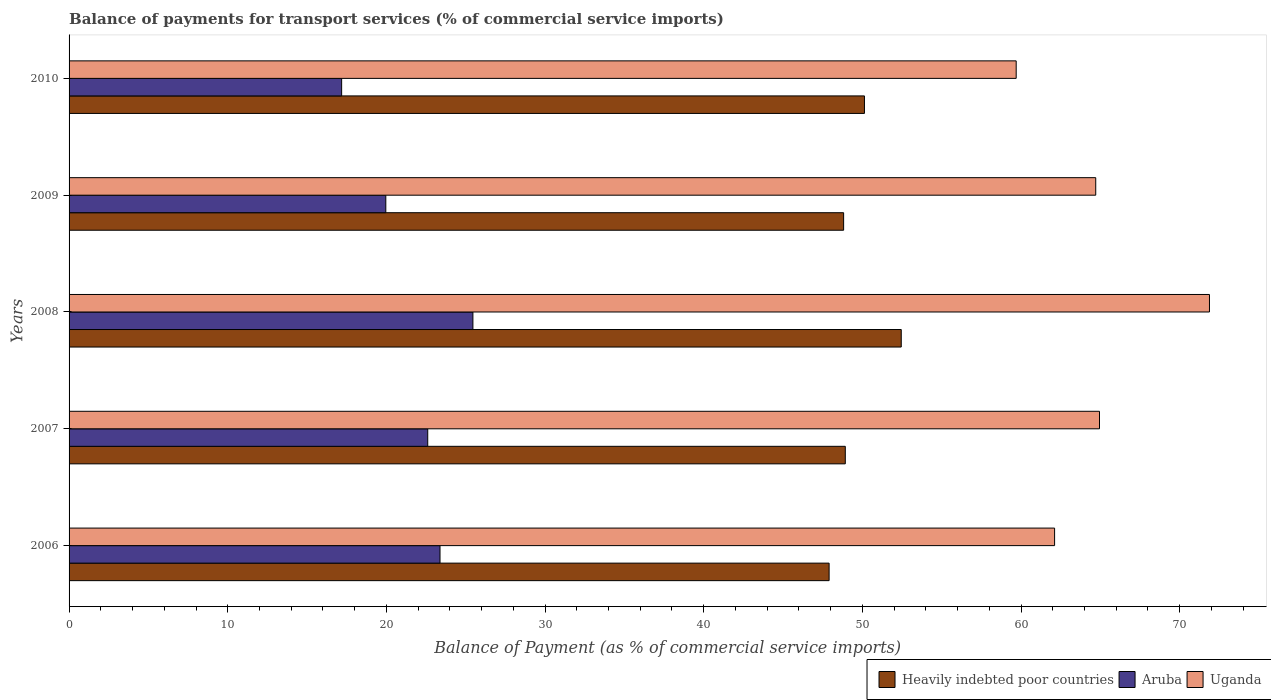How many groups of bars are there?
Your answer should be very brief. 5. Are the number of bars per tick equal to the number of legend labels?
Give a very brief answer. Yes. Are the number of bars on each tick of the Y-axis equal?
Ensure brevity in your answer.  Yes. How many bars are there on the 2nd tick from the top?
Your answer should be compact. 3. How many bars are there on the 5th tick from the bottom?
Your answer should be very brief. 3. What is the label of the 5th group of bars from the top?
Offer a very short reply. 2006. In how many cases, is the number of bars for a given year not equal to the number of legend labels?
Ensure brevity in your answer.  0. What is the balance of payments for transport services in Uganda in 2006?
Make the answer very short. 62.12. Across all years, what is the maximum balance of payments for transport services in Uganda?
Provide a succinct answer. 71.88. Across all years, what is the minimum balance of payments for transport services in Heavily indebted poor countries?
Provide a succinct answer. 47.9. In which year was the balance of payments for transport services in Aruba maximum?
Offer a terse response. 2008. What is the total balance of payments for transport services in Aruba in the graph?
Your response must be concise. 108.58. What is the difference between the balance of payments for transport services in Heavily indebted poor countries in 2007 and that in 2009?
Keep it short and to the point. 0.11. What is the difference between the balance of payments for transport services in Aruba in 2006 and the balance of payments for transport services in Uganda in 2008?
Provide a short and direct response. -48.5. What is the average balance of payments for transport services in Heavily indebted poor countries per year?
Offer a terse response. 49.65. In the year 2007, what is the difference between the balance of payments for transport services in Uganda and balance of payments for transport services in Heavily indebted poor countries?
Your answer should be very brief. 16.02. What is the ratio of the balance of payments for transport services in Heavily indebted poor countries in 2006 to that in 2007?
Your answer should be very brief. 0.98. Is the balance of payments for transport services in Uganda in 2006 less than that in 2008?
Provide a succinct answer. Yes. Is the difference between the balance of payments for transport services in Uganda in 2007 and 2008 greater than the difference between the balance of payments for transport services in Heavily indebted poor countries in 2007 and 2008?
Your answer should be very brief. No. What is the difference between the highest and the second highest balance of payments for transport services in Heavily indebted poor countries?
Offer a terse response. 2.32. What is the difference between the highest and the lowest balance of payments for transport services in Uganda?
Ensure brevity in your answer.  12.18. What does the 1st bar from the top in 2008 represents?
Ensure brevity in your answer.  Uganda. What does the 3rd bar from the bottom in 2008 represents?
Ensure brevity in your answer.  Uganda. Is it the case that in every year, the sum of the balance of payments for transport services in Aruba and balance of payments for transport services in Heavily indebted poor countries is greater than the balance of payments for transport services in Uganda?
Your answer should be very brief. Yes. How many bars are there?
Your response must be concise. 15. Are all the bars in the graph horizontal?
Offer a terse response. Yes. How many years are there in the graph?
Provide a succinct answer. 5. What is the difference between two consecutive major ticks on the X-axis?
Your answer should be very brief. 10. Are the values on the major ticks of X-axis written in scientific E-notation?
Keep it short and to the point. No. Does the graph contain any zero values?
Your answer should be compact. No. Where does the legend appear in the graph?
Your response must be concise. Bottom right. How many legend labels are there?
Offer a terse response. 3. What is the title of the graph?
Ensure brevity in your answer.  Balance of payments for transport services (% of commercial service imports). What is the label or title of the X-axis?
Provide a short and direct response. Balance of Payment (as % of commercial service imports). What is the Balance of Payment (as % of commercial service imports) of Heavily indebted poor countries in 2006?
Ensure brevity in your answer.  47.9. What is the Balance of Payment (as % of commercial service imports) of Aruba in 2006?
Offer a terse response. 23.38. What is the Balance of Payment (as % of commercial service imports) of Uganda in 2006?
Your answer should be very brief. 62.12. What is the Balance of Payment (as % of commercial service imports) in Heavily indebted poor countries in 2007?
Make the answer very short. 48.92. What is the Balance of Payment (as % of commercial service imports) of Aruba in 2007?
Make the answer very short. 22.61. What is the Balance of Payment (as % of commercial service imports) in Uganda in 2007?
Provide a short and direct response. 64.95. What is the Balance of Payment (as % of commercial service imports) of Heavily indebted poor countries in 2008?
Give a very brief answer. 52.45. What is the Balance of Payment (as % of commercial service imports) in Aruba in 2008?
Provide a succinct answer. 25.45. What is the Balance of Payment (as % of commercial service imports) of Uganda in 2008?
Your answer should be compact. 71.88. What is the Balance of Payment (as % of commercial service imports) in Heavily indebted poor countries in 2009?
Keep it short and to the point. 48.82. What is the Balance of Payment (as % of commercial service imports) of Aruba in 2009?
Ensure brevity in your answer.  19.96. What is the Balance of Payment (as % of commercial service imports) of Uganda in 2009?
Keep it short and to the point. 64.71. What is the Balance of Payment (as % of commercial service imports) of Heavily indebted poor countries in 2010?
Offer a very short reply. 50.13. What is the Balance of Payment (as % of commercial service imports) in Aruba in 2010?
Your answer should be very brief. 17.18. What is the Balance of Payment (as % of commercial service imports) of Uganda in 2010?
Your answer should be compact. 59.7. Across all years, what is the maximum Balance of Payment (as % of commercial service imports) of Heavily indebted poor countries?
Offer a very short reply. 52.45. Across all years, what is the maximum Balance of Payment (as % of commercial service imports) of Aruba?
Your answer should be very brief. 25.45. Across all years, what is the maximum Balance of Payment (as % of commercial service imports) of Uganda?
Make the answer very short. 71.88. Across all years, what is the minimum Balance of Payment (as % of commercial service imports) of Heavily indebted poor countries?
Your answer should be compact. 47.9. Across all years, what is the minimum Balance of Payment (as % of commercial service imports) in Aruba?
Keep it short and to the point. 17.18. Across all years, what is the minimum Balance of Payment (as % of commercial service imports) of Uganda?
Your answer should be very brief. 59.7. What is the total Balance of Payment (as % of commercial service imports) in Heavily indebted poor countries in the graph?
Keep it short and to the point. 248.23. What is the total Balance of Payment (as % of commercial service imports) in Aruba in the graph?
Provide a succinct answer. 108.58. What is the total Balance of Payment (as % of commercial service imports) in Uganda in the graph?
Keep it short and to the point. 323.35. What is the difference between the Balance of Payment (as % of commercial service imports) in Heavily indebted poor countries in 2006 and that in 2007?
Make the answer very short. -1.02. What is the difference between the Balance of Payment (as % of commercial service imports) in Aruba in 2006 and that in 2007?
Provide a succinct answer. 0.77. What is the difference between the Balance of Payment (as % of commercial service imports) in Uganda in 2006 and that in 2007?
Keep it short and to the point. -2.83. What is the difference between the Balance of Payment (as % of commercial service imports) in Heavily indebted poor countries in 2006 and that in 2008?
Offer a very short reply. -4.55. What is the difference between the Balance of Payment (as % of commercial service imports) in Aruba in 2006 and that in 2008?
Ensure brevity in your answer.  -2.07. What is the difference between the Balance of Payment (as % of commercial service imports) of Uganda in 2006 and that in 2008?
Provide a succinct answer. -9.76. What is the difference between the Balance of Payment (as % of commercial service imports) in Heavily indebted poor countries in 2006 and that in 2009?
Offer a very short reply. -0.92. What is the difference between the Balance of Payment (as % of commercial service imports) of Aruba in 2006 and that in 2009?
Make the answer very short. 3.42. What is the difference between the Balance of Payment (as % of commercial service imports) of Uganda in 2006 and that in 2009?
Your answer should be compact. -2.59. What is the difference between the Balance of Payment (as % of commercial service imports) of Heavily indebted poor countries in 2006 and that in 2010?
Provide a short and direct response. -2.23. What is the difference between the Balance of Payment (as % of commercial service imports) of Aruba in 2006 and that in 2010?
Make the answer very short. 6.2. What is the difference between the Balance of Payment (as % of commercial service imports) in Uganda in 2006 and that in 2010?
Provide a short and direct response. 2.42. What is the difference between the Balance of Payment (as % of commercial service imports) in Heavily indebted poor countries in 2007 and that in 2008?
Your answer should be very brief. -3.53. What is the difference between the Balance of Payment (as % of commercial service imports) in Aruba in 2007 and that in 2008?
Offer a terse response. -2.85. What is the difference between the Balance of Payment (as % of commercial service imports) in Uganda in 2007 and that in 2008?
Your answer should be very brief. -6.93. What is the difference between the Balance of Payment (as % of commercial service imports) in Heavily indebted poor countries in 2007 and that in 2009?
Provide a short and direct response. 0.11. What is the difference between the Balance of Payment (as % of commercial service imports) of Aruba in 2007 and that in 2009?
Offer a very short reply. 2.64. What is the difference between the Balance of Payment (as % of commercial service imports) in Uganda in 2007 and that in 2009?
Offer a terse response. 0.24. What is the difference between the Balance of Payment (as % of commercial service imports) of Heavily indebted poor countries in 2007 and that in 2010?
Your response must be concise. -1.21. What is the difference between the Balance of Payment (as % of commercial service imports) in Aruba in 2007 and that in 2010?
Give a very brief answer. 5.43. What is the difference between the Balance of Payment (as % of commercial service imports) in Uganda in 2007 and that in 2010?
Keep it short and to the point. 5.25. What is the difference between the Balance of Payment (as % of commercial service imports) of Heavily indebted poor countries in 2008 and that in 2009?
Your response must be concise. 3.63. What is the difference between the Balance of Payment (as % of commercial service imports) of Aruba in 2008 and that in 2009?
Keep it short and to the point. 5.49. What is the difference between the Balance of Payment (as % of commercial service imports) of Uganda in 2008 and that in 2009?
Offer a very short reply. 7.17. What is the difference between the Balance of Payment (as % of commercial service imports) of Heavily indebted poor countries in 2008 and that in 2010?
Your answer should be very brief. 2.32. What is the difference between the Balance of Payment (as % of commercial service imports) of Aruba in 2008 and that in 2010?
Give a very brief answer. 8.27. What is the difference between the Balance of Payment (as % of commercial service imports) in Uganda in 2008 and that in 2010?
Offer a terse response. 12.18. What is the difference between the Balance of Payment (as % of commercial service imports) in Heavily indebted poor countries in 2009 and that in 2010?
Your response must be concise. -1.31. What is the difference between the Balance of Payment (as % of commercial service imports) in Aruba in 2009 and that in 2010?
Your answer should be very brief. 2.78. What is the difference between the Balance of Payment (as % of commercial service imports) of Uganda in 2009 and that in 2010?
Provide a succinct answer. 5.01. What is the difference between the Balance of Payment (as % of commercial service imports) in Heavily indebted poor countries in 2006 and the Balance of Payment (as % of commercial service imports) in Aruba in 2007?
Ensure brevity in your answer.  25.3. What is the difference between the Balance of Payment (as % of commercial service imports) of Heavily indebted poor countries in 2006 and the Balance of Payment (as % of commercial service imports) of Uganda in 2007?
Your response must be concise. -17.04. What is the difference between the Balance of Payment (as % of commercial service imports) of Aruba in 2006 and the Balance of Payment (as % of commercial service imports) of Uganda in 2007?
Ensure brevity in your answer.  -41.57. What is the difference between the Balance of Payment (as % of commercial service imports) of Heavily indebted poor countries in 2006 and the Balance of Payment (as % of commercial service imports) of Aruba in 2008?
Ensure brevity in your answer.  22.45. What is the difference between the Balance of Payment (as % of commercial service imports) of Heavily indebted poor countries in 2006 and the Balance of Payment (as % of commercial service imports) of Uganda in 2008?
Provide a short and direct response. -23.97. What is the difference between the Balance of Payment (as % of commercial service imports) of Aruba in 2006 and the Balance of Payment (as % of commercial service imports) of Uganda in 2008?
Make the answer very short. -48.5. What is the difference between the Balance of Payment (as % of commercial service imports) in Heavily indebted poor countries in 2006 and the Balance of Payment (as % of commercial service imports) in Aruba in 2009?
Ensure brevity in your answer.  27.94. What is the difference between the Balance of Payment (as % of commercial service imports) in Heavily indebted poor countries in 2006 and the Balance of Payment (as % of commercial service imports) in Uganda in 2009?
Your answer should be very brief. -16.81. What is the difference between the Balance of Payment (as % of commercial service imports) of Aruba in 2006 and the Balance of Payment (as % of commercial service imports) of Uganda in 2009?
Provide a short and direct response. -41.33. What is the difference between the Balance of Payment (as % of commercial service imports) of Heavily indebted poor countries in 2006 and the Balance of Payment (as % of commercial service imports) of Aruba in 2010?
Your answer should be compact. 30.73. What is the difference between the Balance of Payment (as % of commercial service imports) of Heavily indebted poor countries in 2006 and the Balance of Payment (as % of commercial service imports) of Uganda in 2010?
Offer a terse response. -11.79. What is the difference between the Balance of Payment (as % of commercial service imports) in Aruba in 2006 and the Balance of Payment (as % of commercial service imports) in Uganda in 2010?
Give a very brief answer. -36.32. What is the difference between the Balance of Payment (as % of commercial service imports) of Heavily indebted poor countries in 2007 and the Balance of Payment (as % of commercial service imports) of Aruba in 2008?
Offer a very short reply. 23.47. What is the difference between the Balance of Payment (as % of commercial service imports) in Heavily indebted poor countries in 2007 and the Balance of Payment (as % of commercial service imports) in Uganda in 2008?
Your answer should be very brief. -22.95. What is the difference between the Balance of Payment (as % of commercial service imports) of Aruba in 2007 and the Balance of Payment (as % of commercial service imports) of Uganda in 2008?
Your answer should be compact. -49.27. What is the difference between the Balance of Payment (as % of commercial service imports) in Heavily indebted poor countries in 2007 and the Balance of Payment (as % of commercial service imports) in Aruba in 2009?
Provide a short and direct response. 28.96. What is the difference between the Balance of Payment (as % of commercial service imports) in Heavily indebted poor countries in 2007 and the Balance of Payment (as % of commercial service imports) in Uganda in 2009?
Provide a succinct answer. -15.79. What is the difference between the Balance of Payment (as % of commercial service imports) in Aruba in 2007 and the Balance of Payment (as % of commercial service imports) in Uganda in 2009?
Your response must be concise. -42.1. What is the difference between the Balance of Payment (as % of commercial service imports) in Heavily indebted poor countries in 2007 and the Balance of Payment (as % of commercial service imports) in Aruba in 2010?
Provide a short and direct response. 31.75. What is the difference between the Balance of Payment (as % of commercial service imports) in Heavily indebted poor countries in 2007 and the Balance of Payment (as % of commercial service imports) in Uganda in 2010?
Give a very brief answer. -10.77. What is the difference between the Balance of Payment (as % of commercial service imports) of Aruba in 2007 and the Balance of Payment (as % of commercial service imports) of Uganda in 2010?
Your response must be concise. -37.09. What is the difference between the Balance of Payment (as % of commercial service imports) of Heavily indebted poor countries in 2008 and the Balance of Payment (as % of commercial service imports) of Aruba in 2009?
Give a very brief answer. 32.49. What is the difference between the Balance of Payment (as % of commercial service imports) in Heavily indebted poor countries in 2008 and the Balance of Payment (as % of commercial service imports) in Uganda in 2009?
Offer a very short reply. -12.26. What is the difference between the Balance of Payment (as % of commercial service imports) in Aruba in 2008 and the Balance of Payment (as % of commercial service imports) in Uganda in 2009?
Make the answer very short. -39.26. What is the difference between the Balance of Payment (as % of commercial service imports) in Heavily indebted poor countries in 2008 and the Balance of Payment (as % of commercial service imports) in Aruba in 2010?
Your answer should be very brief. 35.27. What is the difference between the Balance of Payment (as % of commercial service imports) of Heavily indebted poor countries in 2008 and the Balance of Payment (as % of commercial service imports) of Uganda in 2010?
Ensure brevity in your answer.  -7.24. What is the difference between the Balance of Payment (as % of commercial service imports) of Aruba in 2008 and the Balance of Payment (as % of commercial service imports) of Uganda in 2010?
Provide a succinct answer. -34.24. What is the difference between the Balance of Payment (as % of commercial service imports) of Heavily indebted poor countries in 2009 and the Balance of Payment (as % of commercial service imports) of Aruba in 2010?
Your response must be concise. 31.64. What is the difference between the Balance of Payment (as % of commercial service imports) in Heavily indebted poor countries in 2009 and the Balance of Payment (as % of commercial service imports) in Uganda in 2010?
Give a very brief answer. -10.88. What is the difference between the Balance of Payment (as % of commercial service imports) in Aruba in 2009 and the Balance of Payment (as % of commercial service imports) in Uganda in 2010?
Offer a terse response. -39.73. What is the average Balance of Payment (as % of commercial service imports) of Heavily indebted poor countries per year?
Ensure brevity in your answer.  49.65. What is the average Balance of Payment (as % of commercial service imports) in Aruba per year?
Ensure brevity in your answer.  21.72. What is the average Balance of Payment (as % of commercial service imports) in Uganda per year?
Provide a succinct answer. 64.67. In the year 2006, what is the difference between the Balance of Payment (as % of commercial service imports) of Heavily indebted poor countries and Balance of Payment (as % of commercial service imports) of Aruba?
Ensure brevity in your answer.  24.52. In the year 2006, what is the difference between the Balance of Payment (as % of commercial service imports) of Heavily indebted poor countries and Balance of Payment (as % of commercial service imports) of Uganda?
Your answer should be very brief. -14.21. In the year 2006, what is the difference between the Balance of Payment (as % of commercial service imports) of Aruba and Balance of Payment (as % of commercial service imports) of Uganda?
Your answer should be compact. -38.74. In the year 2007, what is the difference between the Balance of Payment (as % of commercial service imports) of Heavily indebted poor countries and Balance of Payment (as % of commercial service imports) of Aruba?
Offer a terse response. 26.32. In the year 2007, what is the difference between the Balance of Payment (as % of commercial service imports) of Heavily indebted poor countries and Balance of Payment (as % of commercial service imports) of Uganda?
Provide a short and direct response. -16.02. In the year 2007, what is the difference between the Balance of Payment (as % of commercial service imports) of Aruba and Balance of Payment (as % of commercial service imports) of Uganda?
Provide a succinct answer. -42.34. In the year 2008, what is the difference between the Balance of Payment (as % of commercial service imports) of Heavily indebted poor countries and Balance of Payment (as % of commercial service imports) of Aruba?
Your answer should be compact. 27. In the year 2008, what is the difference between the Balance of Payment (as % of commercial service imports) in Heavily indebted poor countries and Balance of Payment (as % of commercial service imports) in Uganda?
Keep it short and to the point. -19.43. In the year 2008, what is the difference between the Balance of Payment (as % of commercial service imports) in Aruba and Balance of Payment (as % of commercial service imports) in Uganda?
Your answer should be very brief. -46.43. In the year 2009, what is the difference between the Balance of Payment (as % of commercial service imports) in Heavily indebted poor countries and Balance of Payment (as % of commercial service imports) in Aruba?
Provide a succinct answer. 28.86. In the year 2009, what is the difference between the Balance of Payment (as % of commercial service imports) in Heavily indebted poor countries and Balance of Payment (as % of commercial service imports) in Uganda?
Provide a short and direct response. -15.89. In the year 2009, what is the difference between the Balance of Payment (as % of commercial service imports) in Aruba and Balance of Payment (as % of commercial service imports) in Uganda?
Give a very brief answer. -44.75. In the year 2010, what is the difference between the Balance of Payment (as % of commercial service imports) in Heavily indebted poor countries and Balance of Payment (as % of commercial service imports) in Aruba?
Your answer should be very brief. 32.95. In the year 2010, what is the difference between the Balance of Payment (as % of commercial service imports) of Heavily indebted poor countries and Balance of Payment (as % of commercial service imports) of Uganda?
Keep it short and to the point. -9.56. In the year 2010, what is the difference between the Balance of Payment (as % of commercial service imports) in Aruba and Balance of Payment (as % of commercial service imports) in Uganda?
Offer a very short reply. -42.52. What is the ratio of the Balance of Payment (as % of commercial service imports) in Heavily indebted poor countries in 2006 to that in 2007?
Ensure brevity in your answer.  0.98. What is the ratio of the Balance of Payment (as % of commercial service imports) of Aruba in 2006 to that in 2007?
Your response must be concise. 1.03. What is the ratio of the Balance of Payment (as % of commercial service imports) of Uganda in 2006 to that in 2007?
Offer a terse response. 0.96. What is the ratio of the Balance of Payment (as % of commercial service imports) of Heavily indebted poor countries in 2006 to that in 2008?
Offer a very short reply. 0.91. What is the ratio of the Balance of Payment (as % of commercial service imports) in Aruba in 2006 to that in 2008?
Provide a short and direct response. 0.92. What is the ratio of the Balance of Payment (as % of commercial service imports) of Uganda in 2006 to that in 2008?
Provide a succinct answer. 0.86. What is the ratio of the Balance of Payment (as % of commercial service imports) in Heavily indebted poor countries in 2006 to that in 2009?
Give a very brief answer. 0.98. What is the ratio of the Balance of Payment (as % of commercial service imports) in Aruba in 2006 to that in 2009?
Your answer should be very brief. 1.17. What is the ratio of the Balance of Payment (as % of commercial service imports) of Uganda in 2006 to that in 2009?
Give a very brief answer. 0.96. What is the ratio of the Balance of Payment (as % of commercial service imports) of Heavily indebted poor countries in 2006 to that in 2010?
Your response must be concise. 0.96. What is the ratio of the Balance of Payment (as % of commercial service imports) of Aruba in 2006 to that in 2010?
Your answer should be very brief. 1.36. What is the ratio of the Balance of Payment (as % of commercial service imports) of Uganda in 2006 to that in 2010?
Ensure brevity in your answer.  1.04. What is the ratio of the Balance of Payment (as % of commercial service imports) of Heavily indebted poor countries in 2007 to that in 2008?
Offer a terse response. 0.93. What is the ratio of the Balance of Payment (as % of commercial service imports) in Aruba in 2007 to that in 2008?
Provide a short and direct response. 0.89. What is the ratio of the Balance of Payment (as % of commercial service imports) in Uganda in 2007 to that in 2008?
Your answer should be very brief. 0.9. What is the ratio of the Balance of Payment (as % of commercial service imports) in Heavily indebted poor countries in 2007 to that in 2009?
Your answer should be very brief. 1. What is the ratio of the Balance of Payment (as % of commercial service imports) in Aruba in 2007 to that in 2009?
Offer a terse response. 1.13. What is the ratio of the Balance of Payment (as % of commercial service imports) of Uganda in 2007 to that in 2009?
Keep it short and to the point. 1. What is the ratio of the Balance of Payment (as % of commercial service imports) of Heavily indebted poor countries in 2007 to that in 2010?
Offer a terse response. 0.98. What is the ratio of the Balance of Payment (as % of commercial service imports) of Aruba in 2007 to that in 2010?
Offer a very short reply. 1.32. What is the ratio of the Balance of Payment (as % of commercial service imports) in Uganda in 2007 to that in 2010?
Your answer should be compact. 1.09. What is the ratio of the Balance of Payment (as % of commercial service imports) of Heavily indebted poor countries in 2008 to that in 2009?
Give a very brief answer. 1.07. What is the ratio of the Balance of Payment (as % of commercial service imports) of Aruba in 2008 to that in 2009?
Your answer should be very brief. 1.27. What is the ratio of the Balance of Payment (as % of commercial service imports) of Uganda in 2008 to that in 2009?
Offer a terse response. 1.11. What is the ratio of the Balance of Payment (as % of commercial service imports) in Heavily indebted poor countries in 2008 to that in 2010?
Provide a short and direct response. 1.05. What is the ratio of the Balance of Payment (as % of commercial service imports) in Aruba in 2008 to that in 2010?
Your response must be concise. 1.48. What is the ratio of the Balance of Payment (as % of commercial service imports) in Uganda in 2008 to that in 2010?
Your answer should be very brief. 1.2. What is the ratio of the Balance of Payment (as % of commercial service imports) of Heavily indebted poor countries in 2009 to that in 2010?
Make the answer very short. 0.97. What is the ratio of the Balance of Payment (as % of commercial service imports) in Aruba in 2009 to that in 2010?
Keep it short and to the point. 1.16. What is the ratio of the Balance of Payment (as % of commercial service imports) of Uganda in 2009 to that in 2010?
Provide a succinct answer. 1.08. What is the difference between the highest and the second highest Balance of Payment (as % of commercial service imports) of Heavily indebted poor countries?
Ensure brevity in your answer.  2.32. What is the difference between the highest and the second highest Balance of Payment (as % of commercial service imports) in Aruba?
Your answer should be compact. 2.07. What is the difference between the highest and the second highest Balance of Payment (as % of commercial service imports) of Uganda?
Keep it short and to the point. 6.93. What is the difference between the highest and the lowest Balance of Payment (as % of commercial service imports) of Heavily indebted poor countries?
Offer a terse response. 4.55. What is the difference between the highest and the lowest Balance of Payment (as % of commercial service imports) of Aruba?
Give a very brief answer. 8.27. What is the difference between the highest and the lowest Balance of Payment (as % of commercial service imports) in Uganda?
Offer a very short reply. 12.18. 